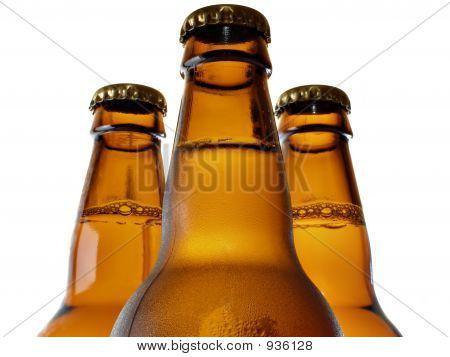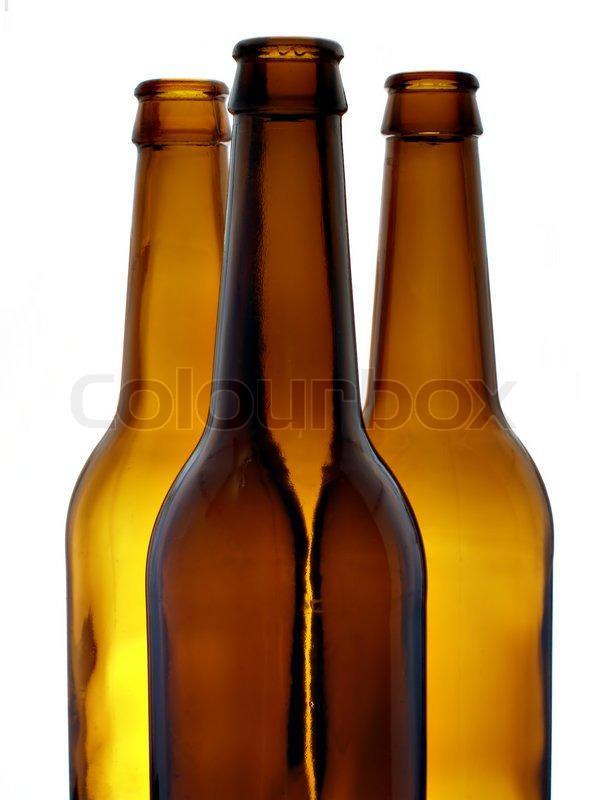The first image is the image on the left, the second image is the image on the right. Analyze the images presented: Is the assertion "One set of bottles is yellow and the other set is more brown." valid? Answer yes or no. No. The first image is the image on the left, the second image is the image on the right. Evaluate the accuracy of this statement regarding the images: "All bottles are shown in groups of three and are capped.". Is it true? Answer yes or no. No. 